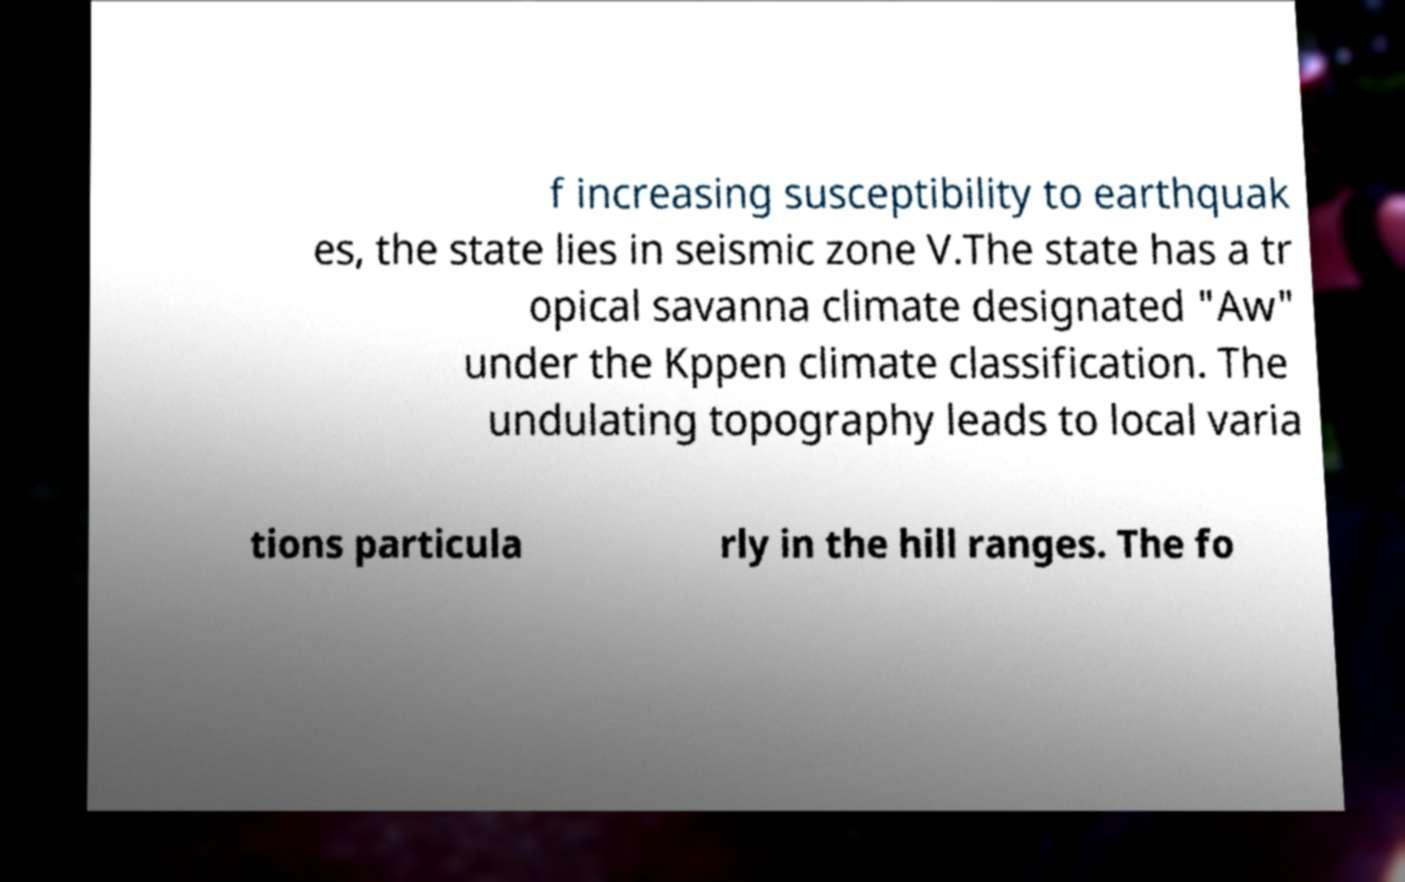Please identify and transcribe the text found in this image. f increasing susceptibility to earthquak es, the state lies in seismic zone V.The state has a tr opical savanna climate designated "Aw" under the Kppen climate classification. The undulating topography leads to local varia tions particula rly in the hill ranges. The fo 